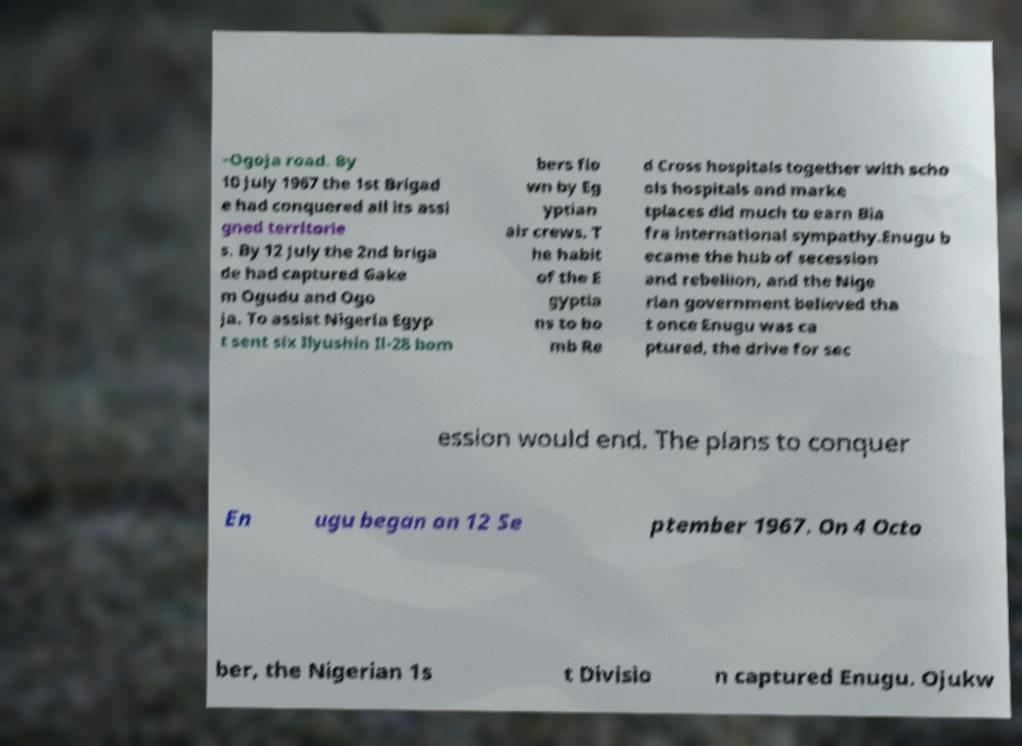Could you assist in decoding the text presented in this image and type it out clearly? –Ogoja road. By 10 July 1967 the 1st Brigad e had conquered all its assi gned territorie s. By 12 July the 2nd briga de had captured Gake m Ogudu and Ogo ja. To assist Nigeria Egyp t sent six Ilyushin Il-28 bom bers flo wn by Eg yptian air crews. T he habit of the E gyptia ns to bo mb Re d Cross hospitals together with scho ols hospitals and marke tplaces did much to earn Bia fra international sympathy.Enugu b ecame the hub of secession and rebellion, and the Nige rian government believed tha t once Enugu was ca ptured, the drive for sec ession would end. The plans to conquer En ugu began on 12 Se ptember 1967. On 4 Octo ber, the Nigerian 1s t Divisio n captured Enugu. Ojukw 